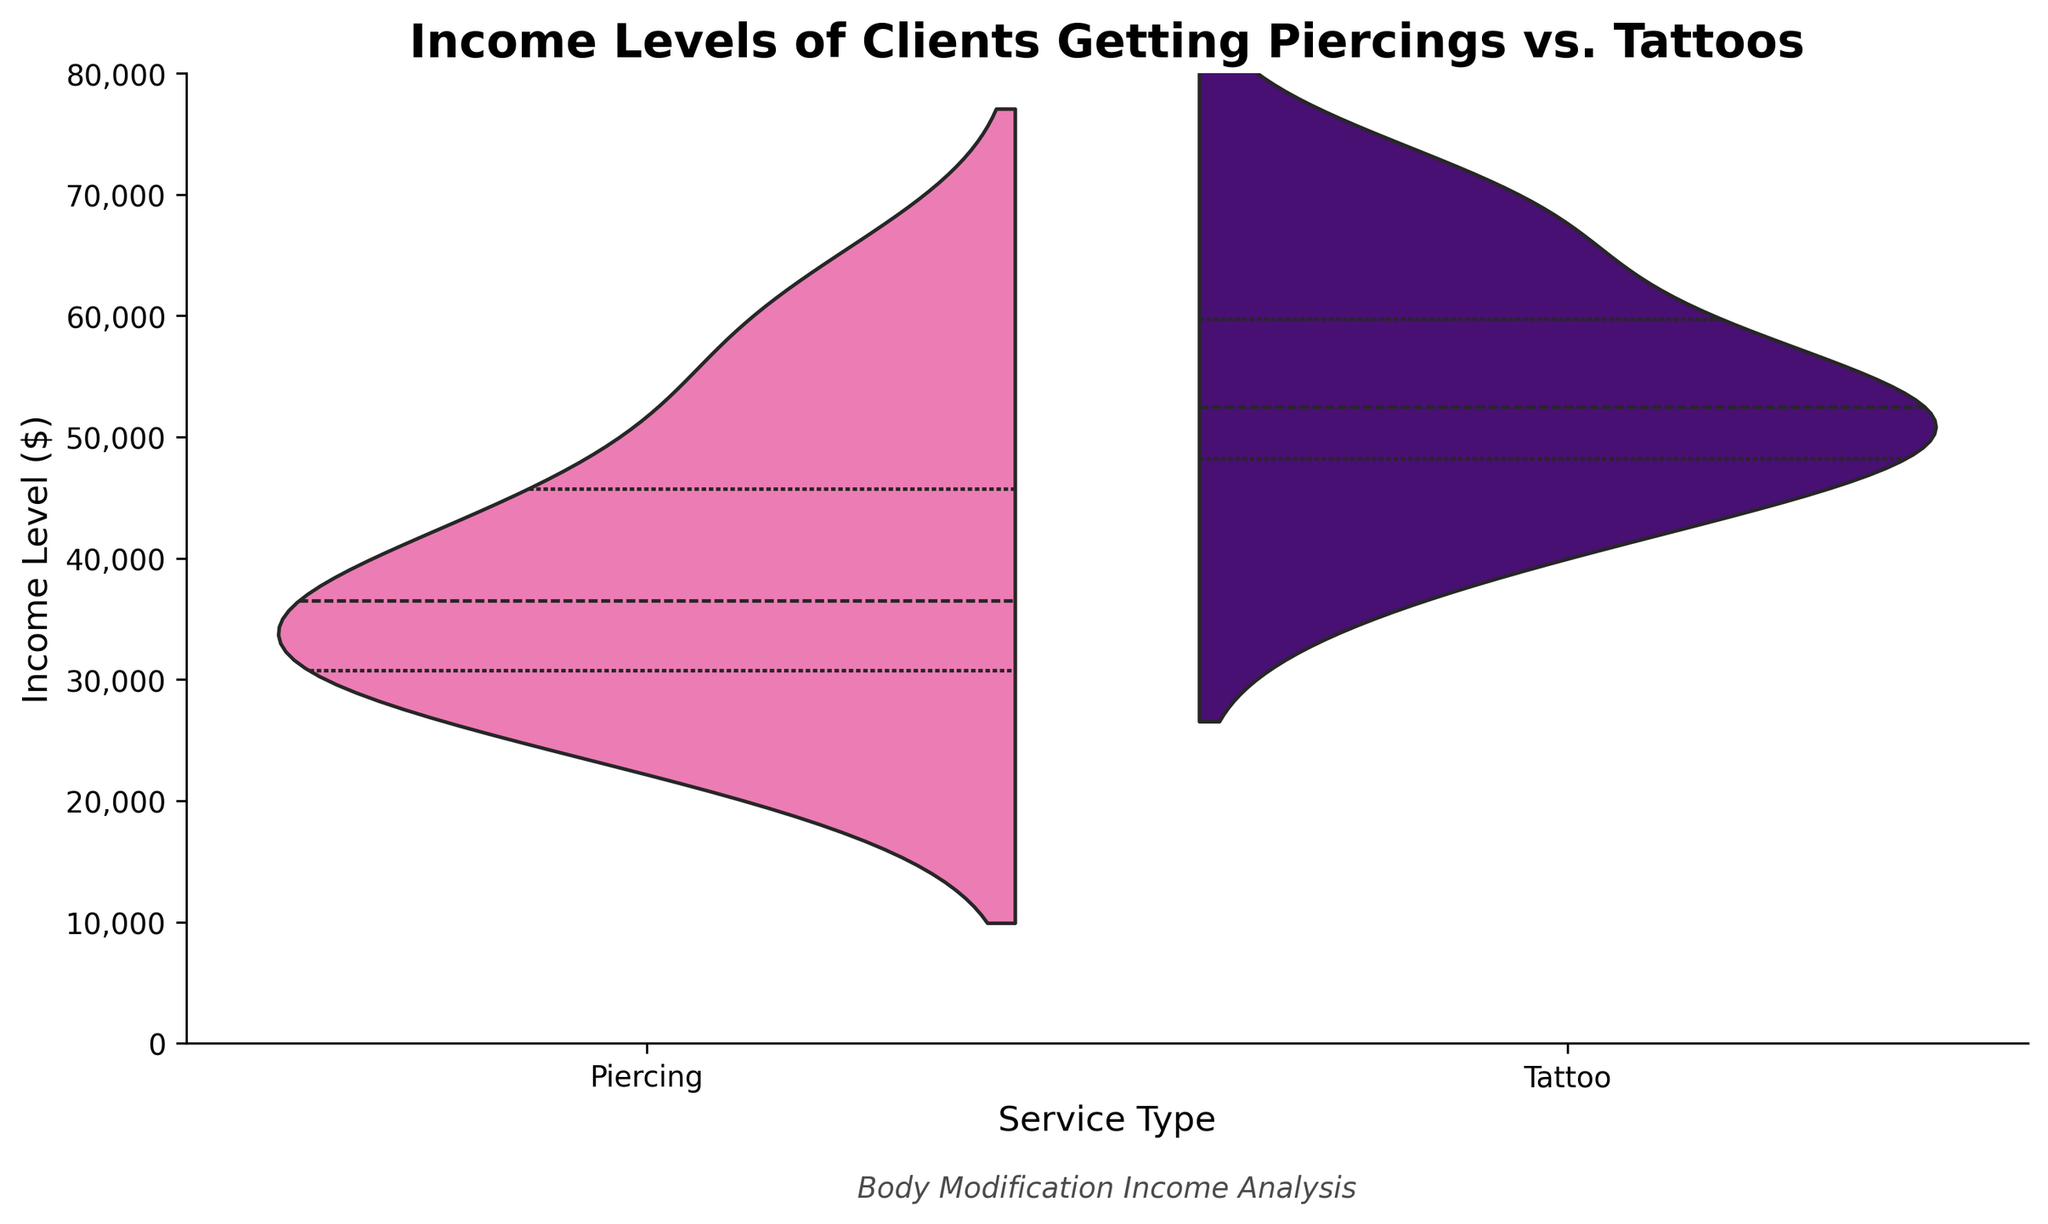What is the title of the chart? The title of the chart is written at the top of the figure and clearly states what the plot is about.
Answer: Income Levels of Clients Getting Piercings vs. Tattoos What are the services compared in the chart? The x-axis labels show the two types of services compared in the chart.
Answer: Piercing and Tattoo What is the color representing the Piercing service? The color indicated in the legend or the split violin plot beside the label "Piercing" represents it.
Answer: Pink What is the range of incomes shown on the y-axis? The y-axis is marked with ticks that indicate the range of values.
Answer: 0 to 80,000 How many clients chose tattoos according to the dataset? We count the number of entries in the dataset with the "ServiceType" as "Tattoo."
Answer: 10 Which service has a higher median income level? The median is where the interquartile ranges (black lines) are densest in the center of the plot for each service type, and the corresponding y-axis value can be compared.
Answer: Tattoo What is the approximate median income level for clients getting piercings? From the center thicker part of the violin plot for Piercing, the median income level can be estimated.
Answer: Approximately $35,000 Which service type shows a wider spread in income levels? The spread refers to the range of the violin plot, so comparing the widths of the bell shapes for both services can answer this.
Answer: Tattoo Which service has more clients with incomes above $50,000? Look at the density of the violin plot tails above the $50,000 mark for each service.
Answer: Tattoo Are any clients shown with an income level greater than $70,000 for tattoos? Check the upper tail of the violin plot for the Tattoo service to see if it extends beyond $70,000.
Answer: Yes 